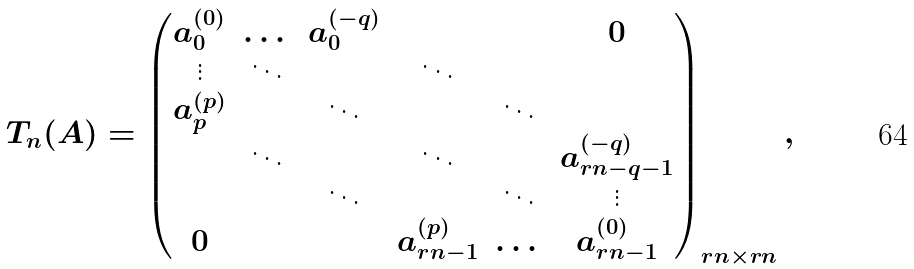<formula> <loc_0><loc_0><loc_500><loc_500>T _ { n } ( A ) = \begin{pmatrix} a _ { 0 } ^ { ( 0 ) } & \dots & a _ { 0 } ^ { ( - q ) } & & & 0 \\ \vdots & \ddots & & \ddots & & \\ a _ { p } ^ { ( p ) } & & \ddots & & \ddots & \\ & \ddots & & \ddots & & a _ { r n - q - 1 } ^ { ( - q ) } \\ & & \ddots & & \ddots & \vdots \\ 0 & & & a _ { r n - 1 } ^ { ( p ) } & \dots & a _ { r n - 1 } ^ { ( 0 ) } \end{pmatrix} _ { r n \times r n } ,</formula> 